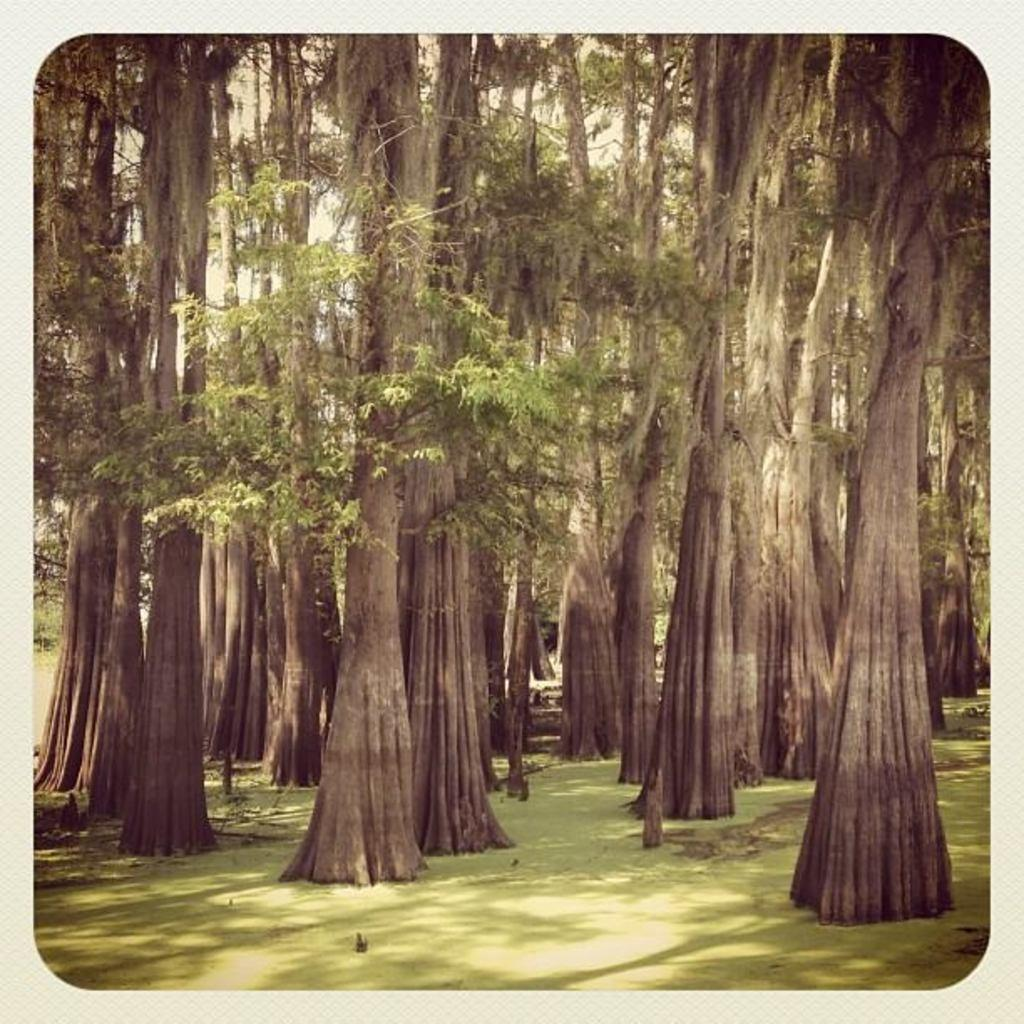What is in the foreground of the image? There is soil in the foreground of the image. What can be seen in the middle of the image? There are trees in the middle of the image. Who is the manager of the trees in the image? There is no manager present in the image, as trees do not require human management. What caused the trees to grow in the image? The cause of the trees' growth is not visible or discernible from the image alone. 